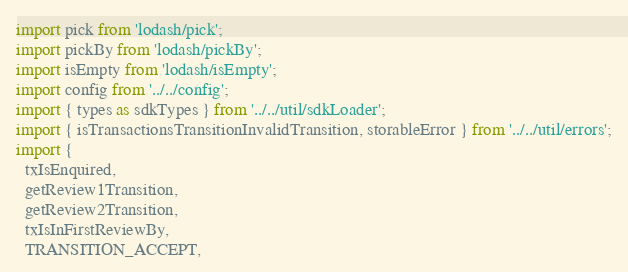Convert code to text. <code><loc_0><loc_0><loc_500><loc_500><_JavaScript_>import pick from 'lodash/pick';
import pickBy from 'lodash/pickBy';
import isEmpty from 'lodash/isEmpty';
import config from '../../config';
import { types as sdkTypes } from '../../util/sdkLoader';
import { isTransactionsTransitionInvalidTransition, storableError } from '../../util/errors';
import {
  txIsEnquired,
  getReview1Transition,
  getReview2Transition,
  txIsInFirstReviewBy,
  TRANSITION_ACCEPT,</code> 